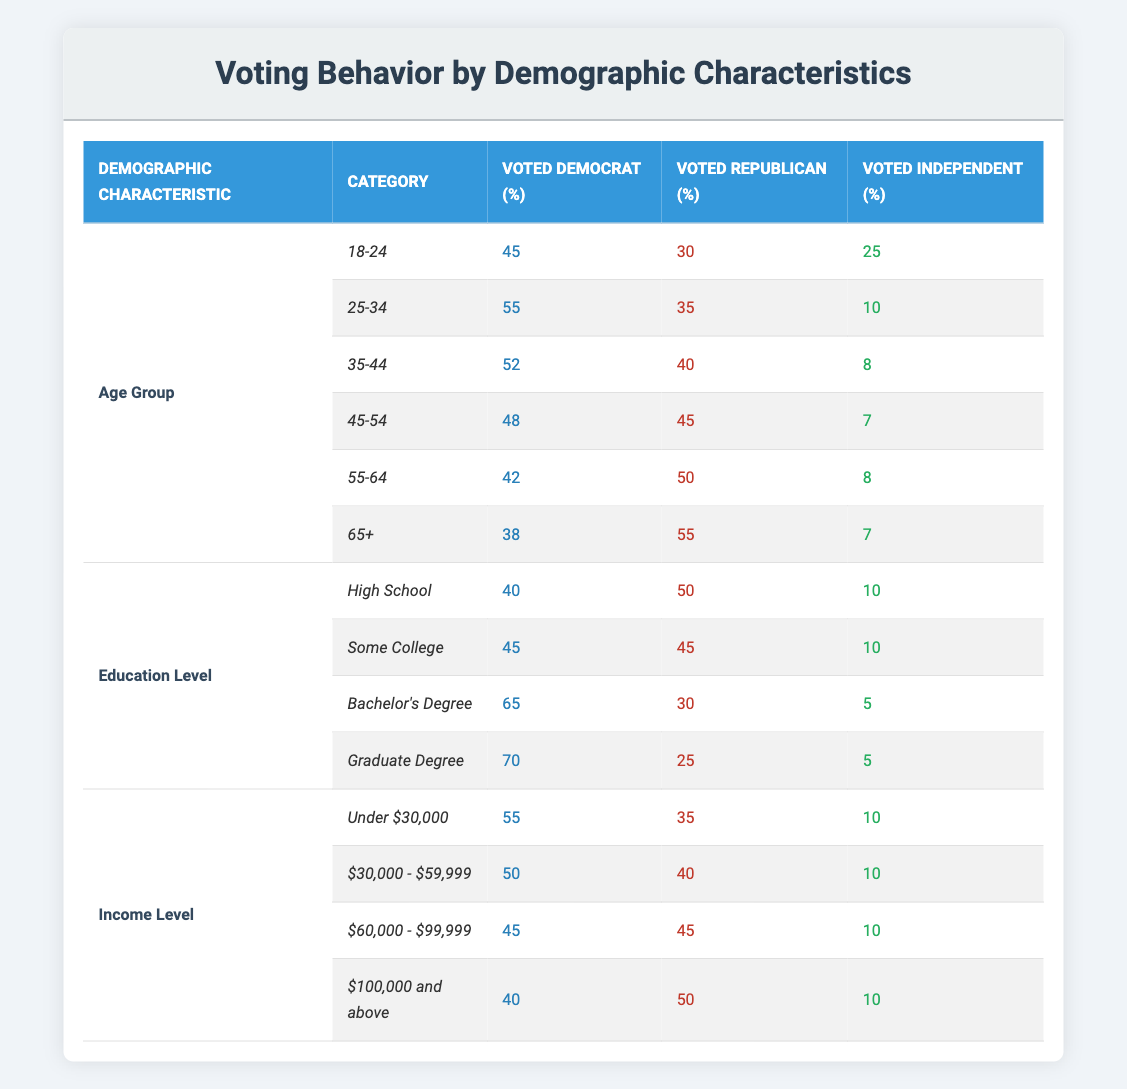What is the percentage of voters aged 25-34 who voted Democrat? According to the table, the percentage of voters aged 25-34 who voted Democrat is 55.
Answer: 55 Which age group had the highest percentage of voters who identified as Independent? To find this, we compare the percentage of Independents across all age groups. The age group 18-24 has 25%, while 35-44 has 8%, 45-54 has 7%, 55-64 has 8%, and 65+ has 7%. Therefore, the 18-24 age group had the highest percentage of Independents at 25%.
Answer: 18-24 What is the average percentage of voters who voted Republican across all education levels? The percentages of Republican voters are 50, 45, 30, and 25 across the education levels. To calculate the average, we sum these percentages: 50 + 45 + 30 + 25 = 150. Then, we divide by the number of categories (4): 150 / 4 = 37.5.
Answer: 37.5 Did more voters with a Bachelor's Degree vote Republican compared to those with a Graduate Degree? The percentage of voters with a Bachelor's Degree who voted Republican is 30%, and for Graduate Degree voters, it is 25%. Since 30% is greater than 25%, more voters with a Bachelor's Degree voted Republican.
Answer: Yes What is the difference in the percentage of voters who identified as Independent between those aged 45-54 and those aged 65 or older? For the age group 45-54, 7% identified as Independent, while for 65+, 7% also identified. The difference is 7% - 7% = 0%.
Answer: 0% What demographic category had the highest overall percentage of Democrats, and what was that percentage? To determine this, we look at the Democrat percentages for all three demographic characteristics: Age (highest is Bachelor's Degree at 65), Education (highest is Graduate Degree at 70), and Income (highest is Under $30,000 at 55). The highest overall is from the Graduate Degree group at 70%.
Answer: Graduate Degree, 70 How many age groups had more than 50% of voters vote Democrat? Checking the age groups: 18-24 (45%), 25-34 (55%), 35-44 (52%), 45-54 (48%), 55-64 (42%), and 65+ (38%). Only the age groups 25-34 and 35-44 had more than 50% voting Democrat. Therefore, there are 2 age groups that had over 50%.
Answer: 2 